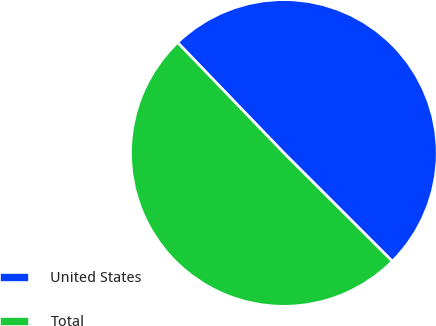<chart> <loc_0><loc_0><loc_500><loc_500><pie_chart><fcel>United States<fcel>Total<nl><fcel>49.68%<fcel>50.32%<nl></chart> 